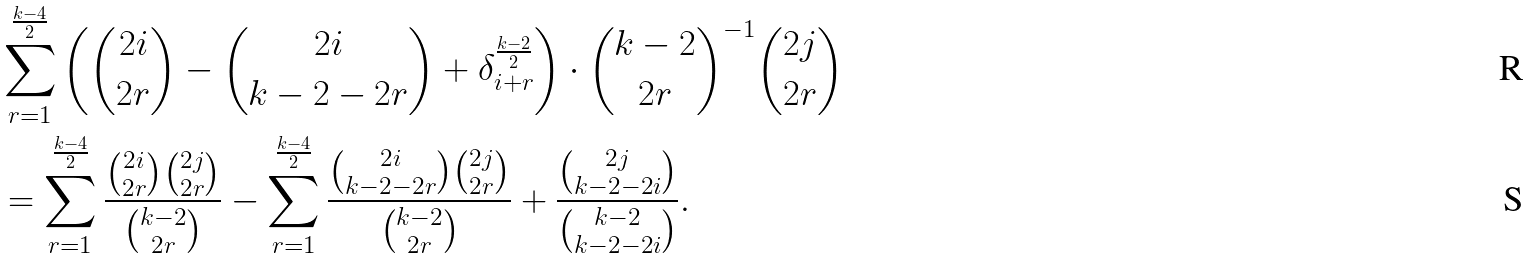Convert formula to latex. <formula><loc_0><loc_0><loc_500><loc_500>& \sum _ { r = 1 } ^ { \frac { k - 4 } { 2 } } \left ( \binom { 2 i } { 2 r } - \binom { 2 i } { k - 2 - 2 r } + \delta _ { i + r } ^ { \frac { k - 2 } { 2 } } \right ) \cdot \binom { k - 2 } { 2 r } ^ { - 1 } \binom { 2 j } { 2 r } \\ & = \sum _ { r = 1 } ^ { \frac { k - 4 } { 2 } } \frac { \binom { 2 i } { 2 r } \binom { 2 j } { 2 r } } { \binom { k - 2 } { 2 r } } - \sum _ { r = 1 } ^ { \frac { k - 4 } { 2 } } \frac { \binom { 2 i } { k - 2 - 2 r } \binom { 2 j } { 2 r } } { \binom { k - 2 } { 2 r } } + \frac { \binom { 2 j } { k - 2 - 2 i } } { \binom { k - 2 } { k - 2 - 2 i } } .</formula> 